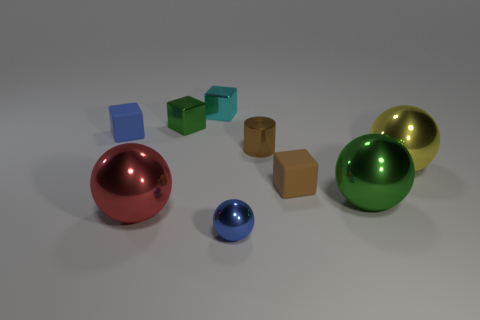Subtract all large red spheres. How many spheres are left? 3 Add 1 tiny brown matte cubes. How many objects exist? 10 Subtract all cyan cubes. How many cubes are left? 3 Subtract 2 spheres. How many spheres are left? 2 Subtract all yellow spheres. How many green blocks are left? 1 Subtract all small yellow rubber objects. Subtract all large yellow objects. How many objects are left? 8 Add 2 big green metal balls. How many big green metal balls are left? 3 Add 5 large red metallic cylinders. How many large red metallic cylinders exist? 5 Subtract 1 brown cylinders. How many objects are left? 8 Subtract all cylinders. How many objects are left? 8 